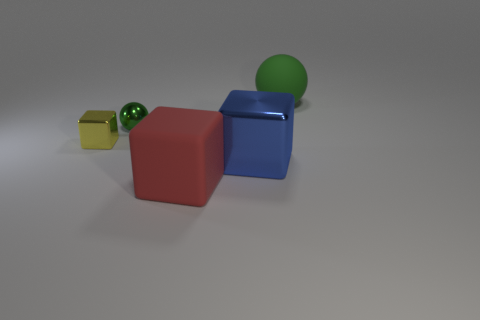Add 3 green metallic balls. How many objects exist? 8 Subtract all blocks. How many objects are left? 2 Add 5 large red cubes. How many large red cubes exist? 6 Subtract 0 cyan cylinders. How many objects are left? 5 Subtract all big metallic cubes. Subtract all cyan shiny spheres. How many objects are left? 4 Add 1 large blue blocks. How many large blue blocks are left? 2 